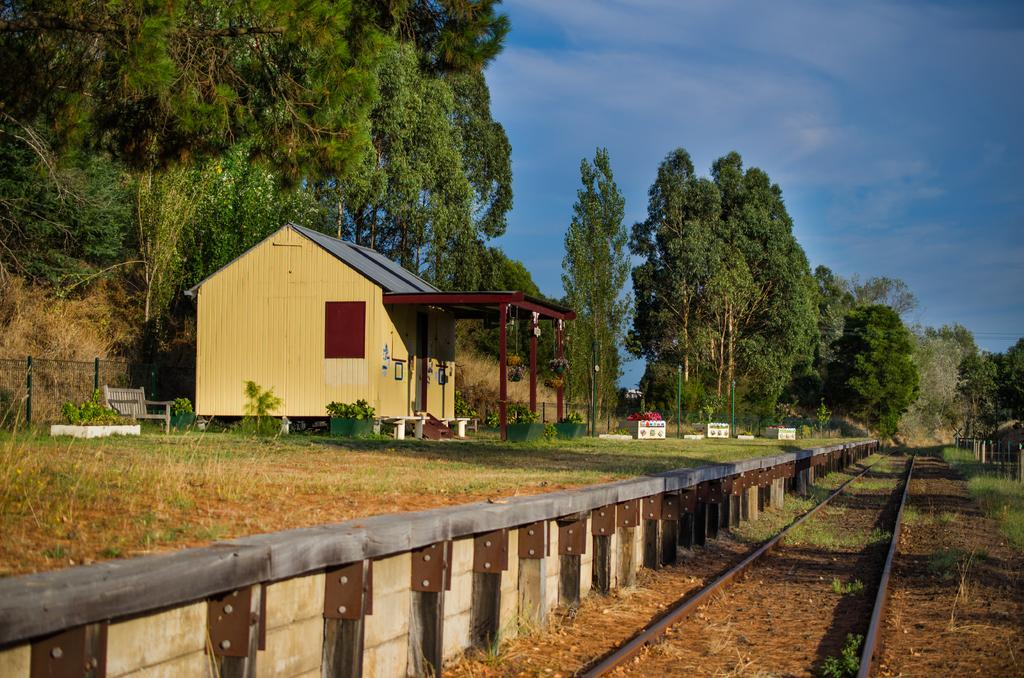What type of house is in the image? There is a wooden house in the image. What can be seen in the background of the image? There are trees in the background of the image, and they are green. What is the color of the sky in the image? The sky is blue in the image. What is the purpose of the fencing in the image? The fencing in the image serves as a boundary or barrier. What is the track visible in the image used for? The track visible in the image is likely used for walking, running, or other outdoor activities. Can you see any stamps on the wooden house in the image? There are no stamps visible on the wooden house in the image. Is there a cave in the background of the image? There is no cave present in the image; only trees are visible in the background. 